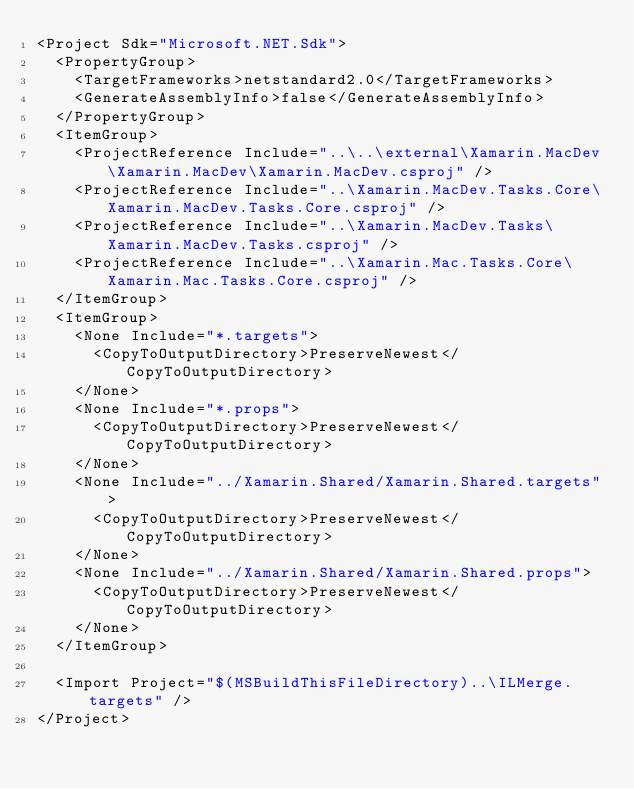Convert code to text. <code><loc_0><loc_0><loc_500><loc_500><_XML_><Project Sdk="Microsoft.NET.Sdk">
  <PropertyGroup>
    <TargetFrameworks>netstandard2.0</TargetFrameworks>
    <GenerateAssemblyInfo>false</GenerateAssemblyInfo>
  </PropertyGroup>
  <ItemGroup>
    <ProjectReference Include="..\..\external\Xamarin.MacDev\Xamarin.MacDev\Xamarin.MacDev.csproj" />
    <ProjectReference Include="..\Xamarin.MacDev.Tasks.Core\Xamarin.MacDev.Tasks.Core.csproj" />
    <ProjectReference Include="..\Xamarin.MacDev.Tasks\Xamarin.MacDev.Tasks.csproj" />
    <ProjectReference Include="..\Xamarin.Mac.Tasks.Core\Xamarin.Mac.Tasks.Core.csproj" />
  </ItemGroup>
  <ItemGroup>
    <None Include="*.targets">
      <CopyToOutputDirectory>PreserveNewest</CopyToOutputDirectory>
    </None>
    <None Include="*.props">
      <CopyToOutputDirectory>PreserveNewest</CopyToOutputDirectory>
    </None>
    <None Include="../Xamarin.Shared/Xamarin.Shared.targets">
      <CopyToOutputDirectory>PreserveNewest</CopyToOutputDirectory>
    </None>
    <None Include="../Xamarin.Shared/Xamarin.Shared.props">
      <CopyToOutputDirectory>PreserveNewest</CopyToOutputDirectory>
    </None>
  </ItemGroup>

  <Import Project="$(MSBuildThisFileDirectory)..\ILMerge.targets" />
</Project>
</code> 